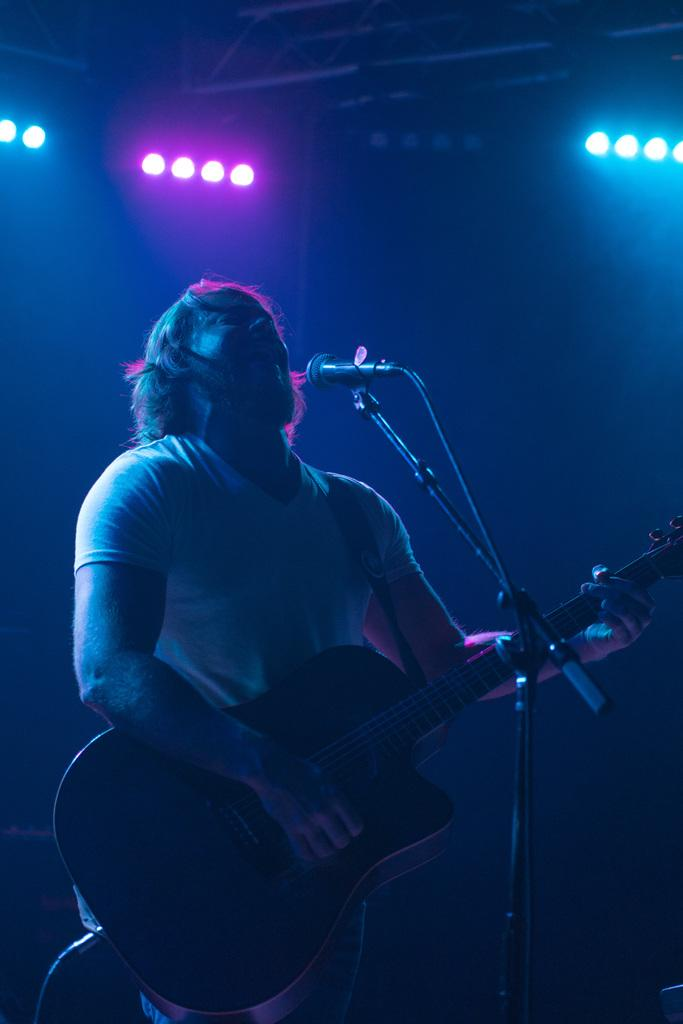What is the person in the image doing? The person is standing, playing a guitar, and singing. What object is the person using to amplify their voice? There is a microphone in the image. What can be seen in the background of the image? There are lights visible in the image. How many cars are parked behind the person in the image? There are no cars visible in the image. What type of cloud can be seen in the image? There is no cloud present in the image. 